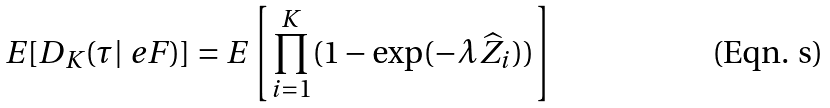Convert formula to latex. <formula><loc_0><loc_0><loc_500><loc_500>E [ D _ { K } ( \tau | \ e F ) ] = E \left [ \prod _ { i = 1 } ^ { K } ( 1 - \exp ( - \lambda \widehat { Z } _ { i } ) ) \right ]</formula> 